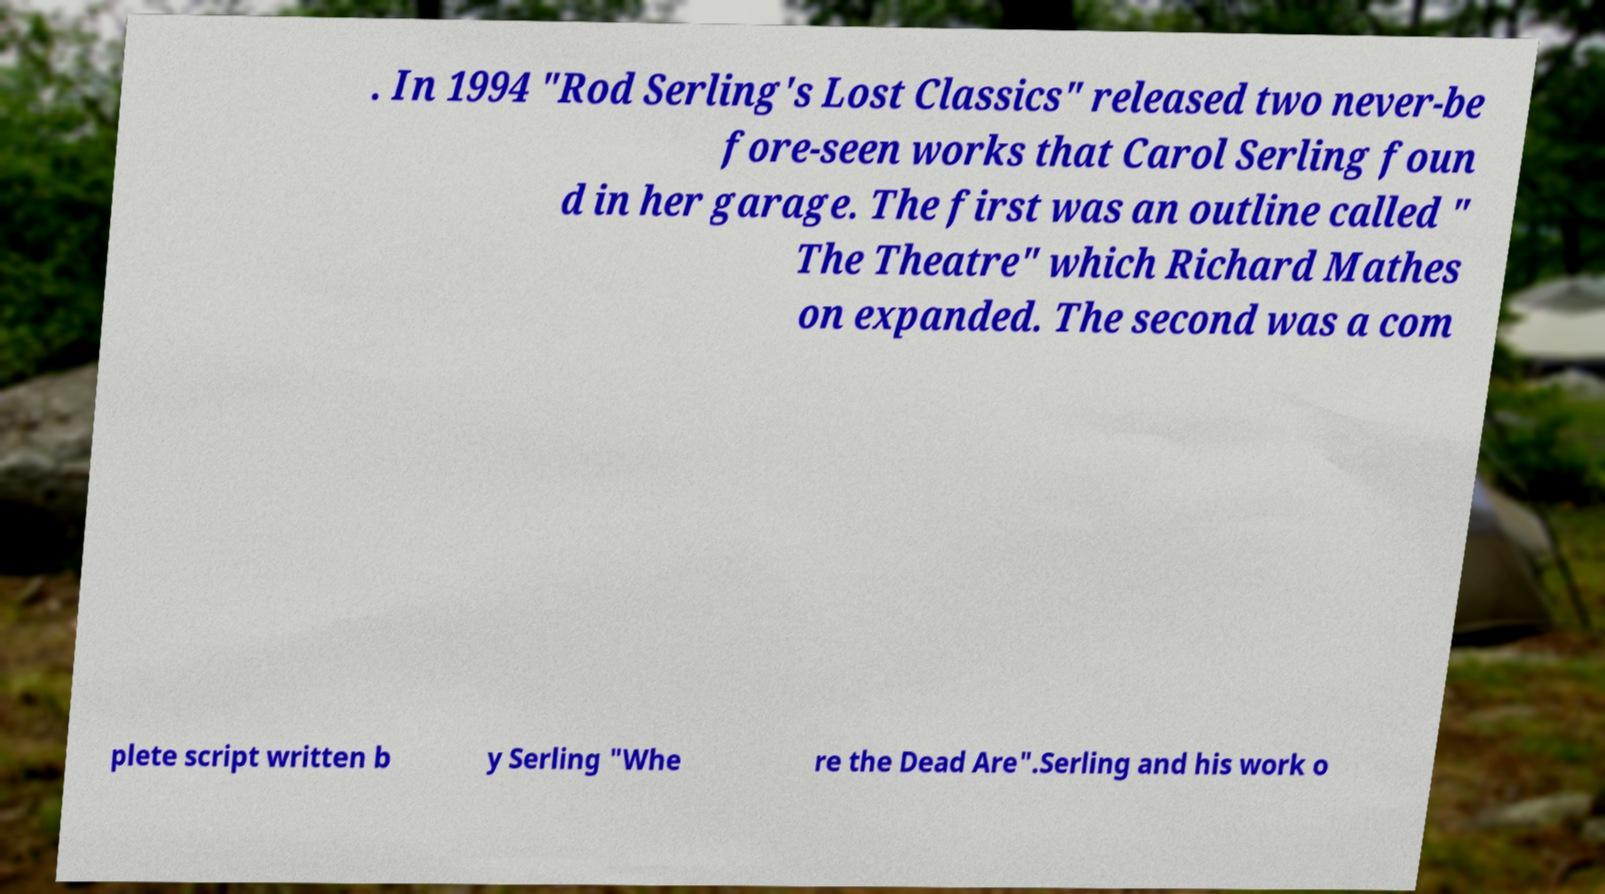Can you accurately transcribe the text from the provided image for me? . In 1994 "Rod Serling's Lost Classics" released two never-be fore-seen works that Carol Serling foun d in her garage. The first was an outline called " The Theatre" which Richard Mathes on expanded. The second was a com plete script written b y Serling "Whe re the Dead Are".Serling and his work o 